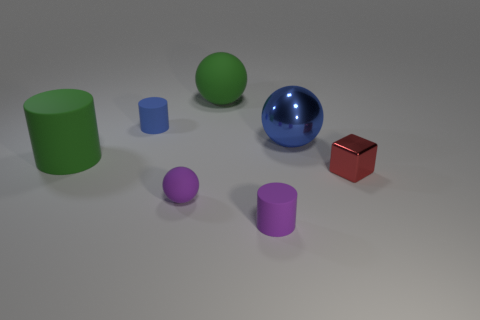Is there anything else that has the same shape as the red metallic object?
Provide a short and direct response. No. The purple thing on the left side of the green thing behind the big green rubber thing in front of the blue rubber cylinder is what shape?
Provide a succinct answer. Sphere. The small purple object that is made of the same material as the small purple ball is what shape?
Give a very brief answer. Cylinder. What size is the green matte ball?
Ensure brevity in your answer.  Large. Do the red object and the blue matte thing have the same size?
Give a very brief answer. Yes. How many things are tiny matte objects that are behind the small shiny cube or matte things left of the tiny ball?
Keep it short and to the point. 2. How many cylinders are behind the green thing that is to the left of the tiny matte cylinder that is behind the tiny purple cylinder?
Provide a short and direct response. 1. There is a cylinder in front of the large green matte cylinder; what is its size?
Provide a succinct answer. Small. How many yellow matte balls have the same size as the metal block?
Make the answer very short. 0. Do the green rubber cylinder and the rubber cylinder behind the big cylinder have the same size?
Your answer should be compact. No. 